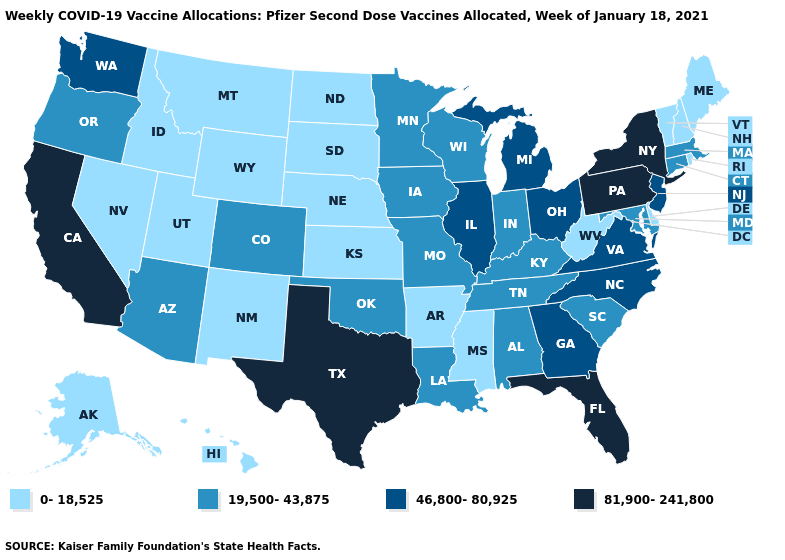Name the states that have a value in the range 19,500-43,875?
Concise answer only. Alabama, Arizona, Colorado, Connecticut, Indiana, Iowa, Kentucky, Louisiana, Maryland, Massachusetts, Minnesota, Missouri, Oklahoma, Oregon, South Carolina, Tennessee, Wisconsin. Among the states that border Virginia , which have the highest value?
Be succinct. North Carolina. Among the states that border Virginia , does West Virginia have the lowest value?
Short answer required. Yes. Name the states that have a value in the range 19,500-43,875?
Short answer required. Alabama, Arizona, Colorado, Connecticut, Indiana, Iowa, Kentucky, Louisiana, Maryland, Massachusetts, Minnesota, Missouri, Oklahoma, Oregon, South Carolina, Tennessee, Wisconsin. Among the states that border Nevada , which have the lowest value?
Answer briefly. Idaho, Utah. What is the highest value in the USA?
Quick response, please. 81,900-241,800. Name the states that have a value in the range 46,800-80,925?
Answer briefly. Georgia, Illinois, Michigan, New Jersey, North Carolina, Ohio, Virginia, Washington. What is the highest value in the USA?
Be succinct. 81,900-241,800. Does West Virginia have the lowest value in the South?
Be succinct. Yes. What is the value of South Carolina?
Short answer required. 19,500-43,875. What is the value of Alabama?
Short answer required. 19,500-43,875. Does Wisconsin have a higher value than Arkansas?
Keep it brief. Yes. Does Alabama have a lower value than Florida?
Short answer required. Yes. What is the highest value in the MidWest ?
Give a very brief answer. 46,800-80,925. 